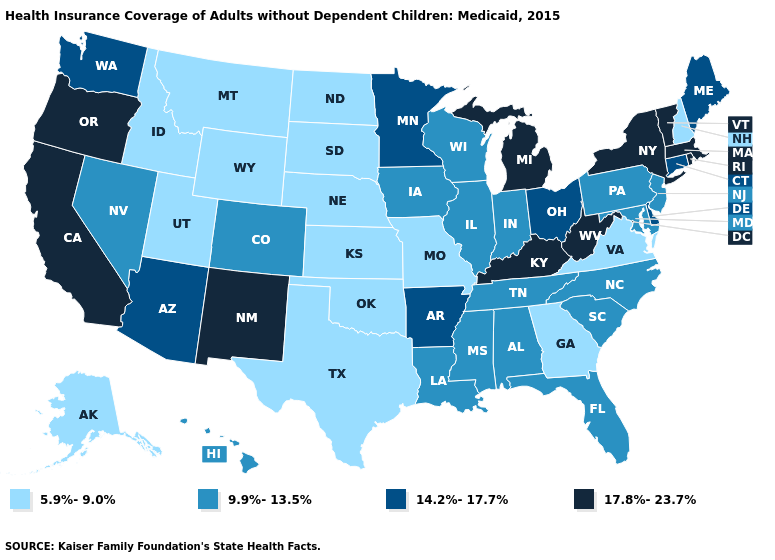Does Georgia have the highest value in the South?
Be succinct. No. What is the highest value in states that border Utah?
Answer briefly. 17.8%-23.7%. What is the lowest value in states that border Pennsylvania?
Be succinct. 9.9%-13.5%. What is the value of South Dakota?
Short answer required. 5.9%-9.0%. Which states have the highest value in the USA?
Be succinct. California, Kentucky, Massachusetts, Michigan, New Mexico, New York, Oregon, Rhode Island, Vermont, West Virginia. Does the map have missing data?
Short answer required. No. Among the states that border New York , which have the highest value?
Be succinct. Massachusetts, Vermont. What is the value of New York?
Write a very short answer. 17.8%-23.7%. Which states hav the highest value in the West?
Concise answer only. California, New Mexico, Oregon. What is the lowest value in the USA?
Quick response, please. 5.9%-9.0%. What is the value of Idaho?
Write a very short answer. 5.9%-9.0%. Among the states that border Missouri , which have the lowest value?
Answer briefly. Kansas, Nebraska, Oklahoma. Name the states that have a value in the range 5.9%-9.0%?
Give a very brief answer. Alaska, Georgia, Idaho, Kansas, Missouri, Montana, Nebraska, New Hampshire, North Dakota, Oklahoma, South Dakota, Texas, Utah, Virginia, Wyoming. Does New York have a higher value than Oregon?
Give a very brief answer. No. Which states hav the highest value in the West?
Be succinct. California, New Mexico, Oregon. 